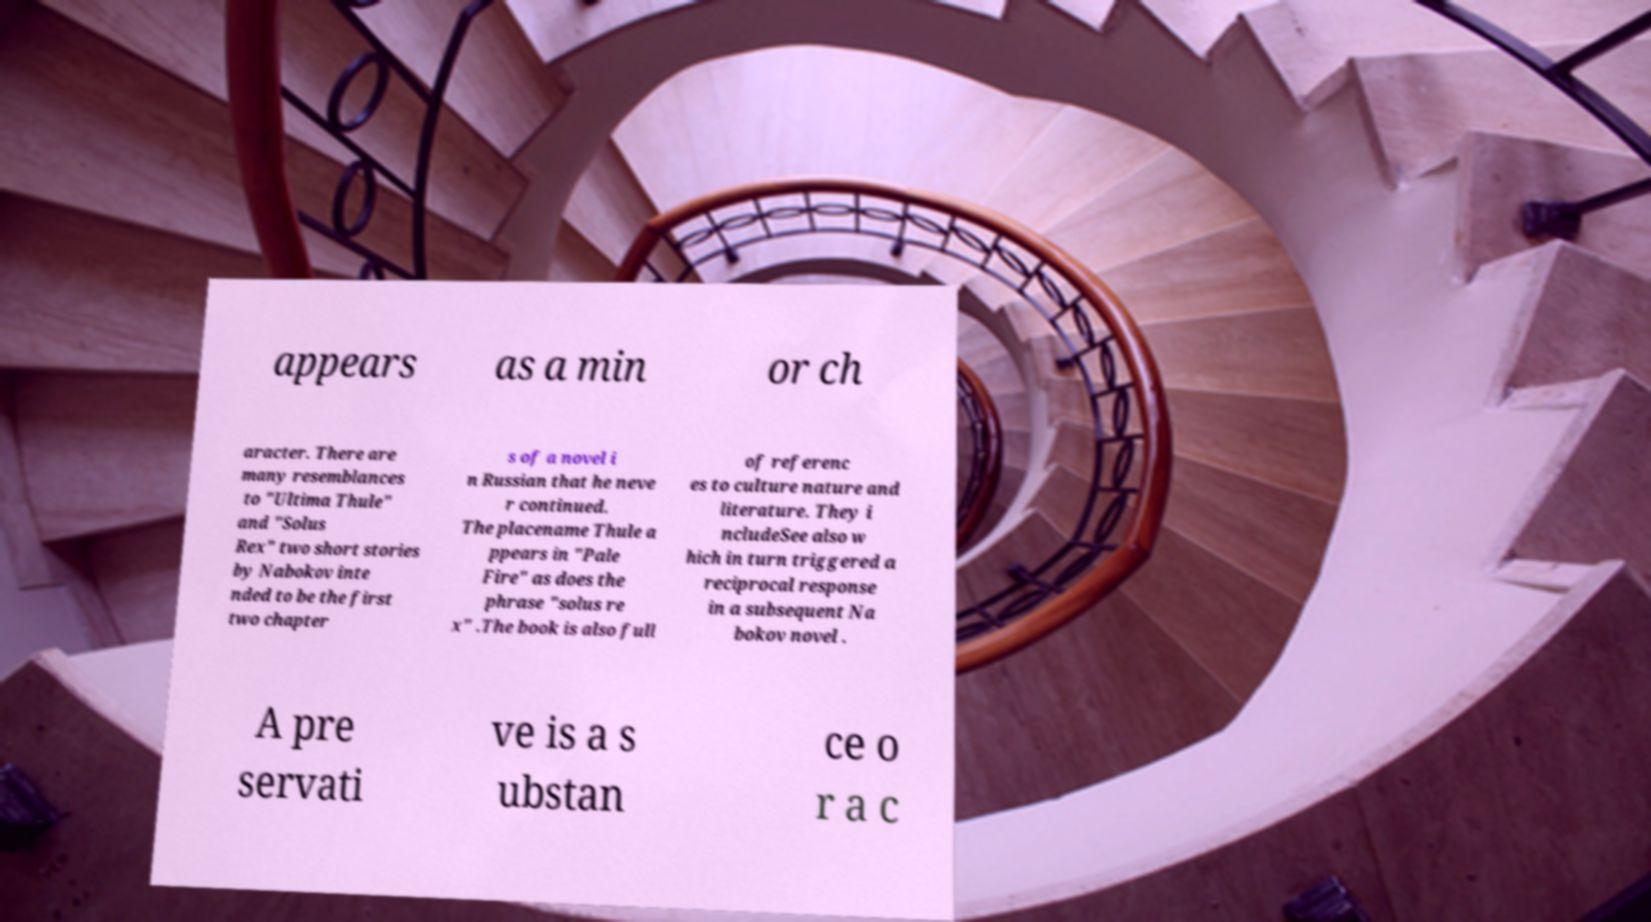I need the written content from this picture converted into text. Can you do that? appears as a min or ch aracter. There are many resemblances to "Ultima Thule" and "Solus Rex" two short stories by Nabokov inte nded to be the first two chapter s of a novel i n Russian that he neve r continued. The placename Thule a ppears in "Pale Fire" as does the phrase "solus re x" .The book is also full of referenc es to culture nature and literature. They i ncludeSee also w hich in turn triggered a reciprocal response in a subsequent Na bokov novel . A pre servati ve is a s ubstan ce o r a c 